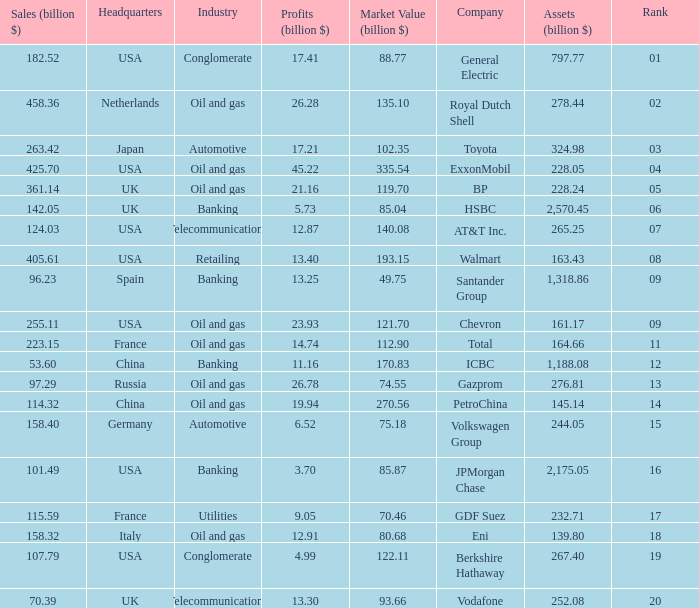Name the lowest Market Value (billion $) which has Assets (billion $) larger than 276.81, and a Company of toyota, and Profits (billion $) larger than 17.21? None. 